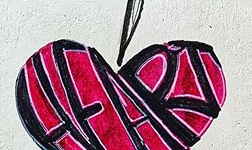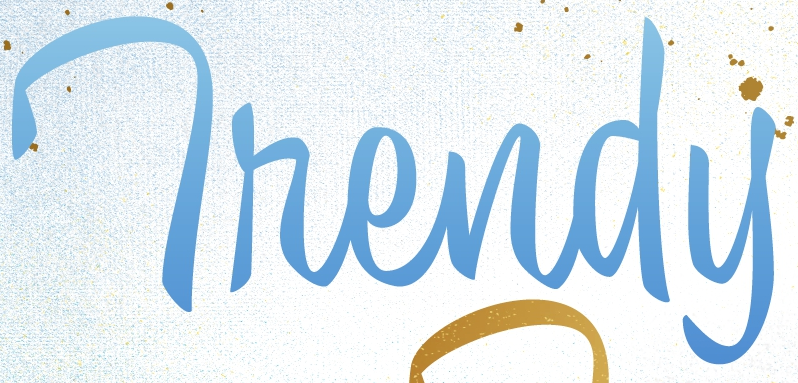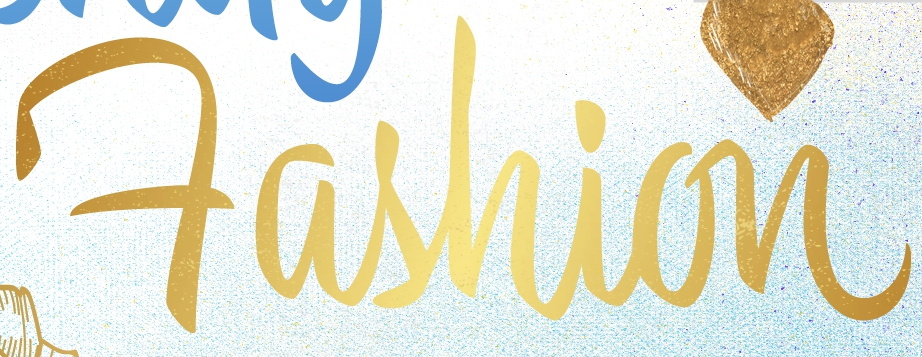What text appears in these images from left to right, separated by a semicolon? HFART; Thendy; Fashion 